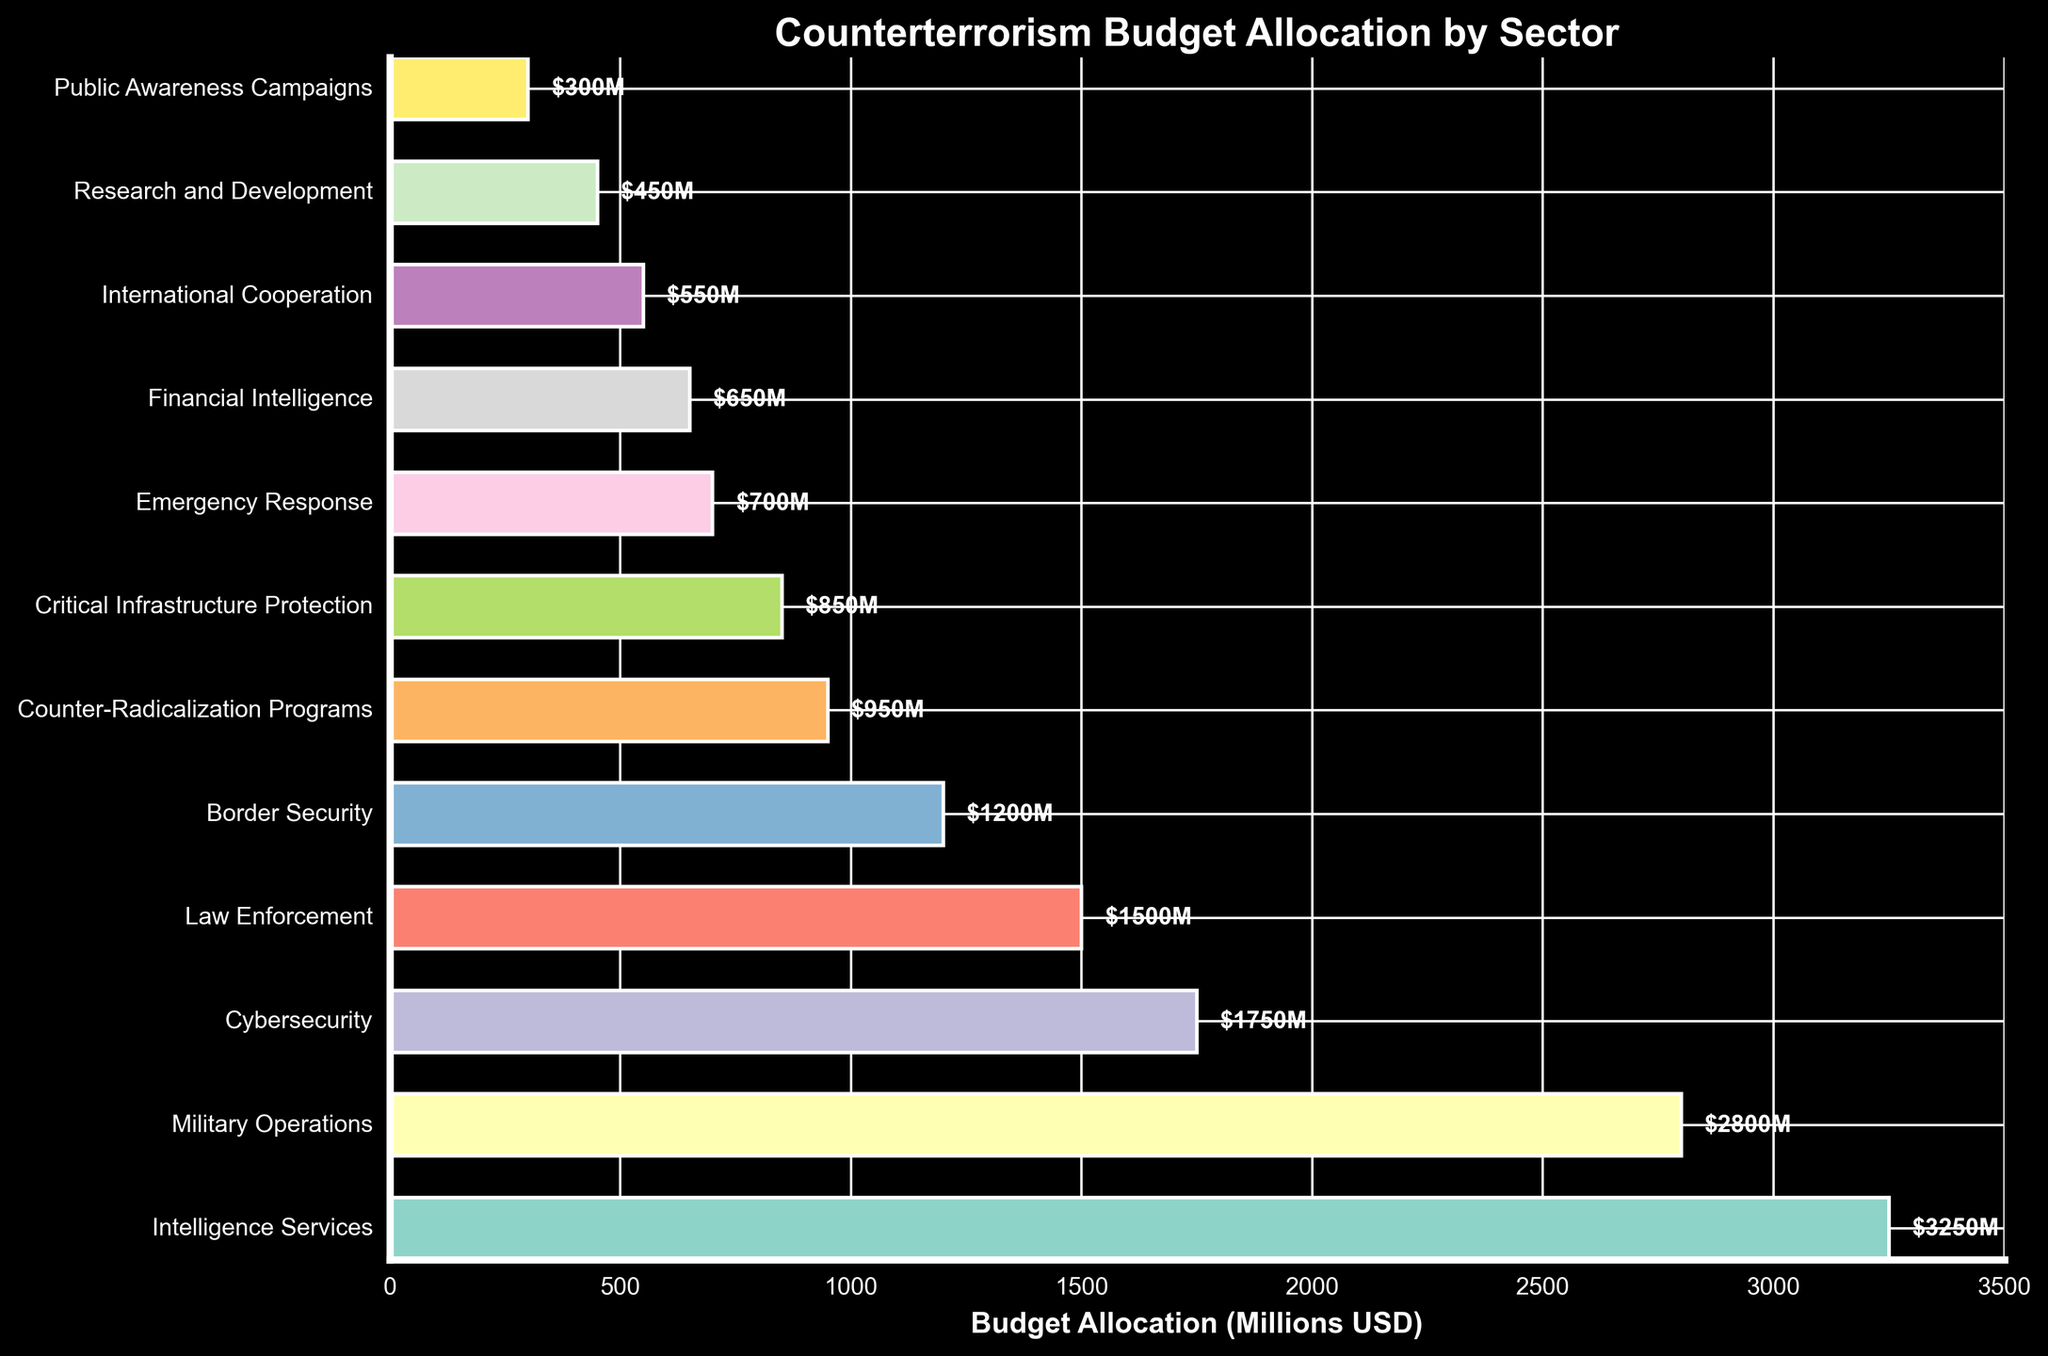Which sector has the highest budget allocation? The bar chart shows the sectors with their respective budget allocations. The longest bar represents the sector with the highest budget. In this case, Intelligence Services has the longest bar.
Answer: Intelligence Services What is the total budget allocation for Border Security and Counter-Radicalization Programs? Border Security has a budget allocation of $1200M, and Counter-Radicalization Programs have $950M. Adding these two amounts together gives $1200M + $950M = $2150M.
Answer: $2150M How much more budget is allocated to Intelligence Services compared to Research and Development? The budget allocation for Intelligence Services is $3250M, and for Research and Development, it is $450M. Subtracting the budget for Research and Development from Intelligence Services gives $3250M - $450M = $2800M.
Answer: $2800M Which sector has the smallest budget allocation, and what is its value? The shortest bar represents the sector with the smallest budget allocation. Public Awareness Campaigns have the shortest bar with a budget allocation of $300M.
Answer: Public Awareness Campaigns, $300M What is the average budget allocation for Cybersecurity, Law Enforcement, and Border Security? The budget allocations are Cybersecurity: $1750M, Law Enforcement: $1500M, and Border Security: $1200M. Summing these amounts gives $1750M + $1500M + $1200M = $4450M. Dividing by the number of sectors (3) gives $4450M / 3 = approximately $1483.33M.
Answer: Approximately $1483.33M How does the budget allocation of Military Operations compare to that of Cybersecurity? Military Operations have a budget allocation of $2800M, and Cybersecurity has $1750M. Comparing these two values, Military Operations have a higher budget allocation than Cybersecurity.
Answer: Military Operations have a higher budget What is the combined budget allocation for sectors with a budget greater than or equal to $1500M? The sectors with budgets greater than or equal to $1500M are Intelligence Services ($3250M), Military Operations ($2800M), Cybersecurity ($1750M), and Law Enforcement ($1500M). Summing these amounts gives $3250M + $2800M + $1750M + $1500M = $9300M.
Answer: $9300M Rank the top three sectors by their budget allocation. By looking at the length of the bars, the top three sectors by budget allocation are: Intelligence Services ($3250M), Military Operations ($2800M), and Cybersecurity ($1750M).
Answer: Intelligence Services, Military Operations, Cybersecurity What is the difference in budget allocation between Emergency Response and Financial Intelligence? Emergency Response has a budget allocation of $700M, and Financial Intelligence has $650M. The difference is $700M - $650M = $50M.
Answer: $50M Which sector has a budget allocation closest to $1000M? The sector with a budget allocation closest to $1000M is Counter-Radicalization Programs, with a budget allocation of $950M.
Answer: Counter-Radicalization Programs 